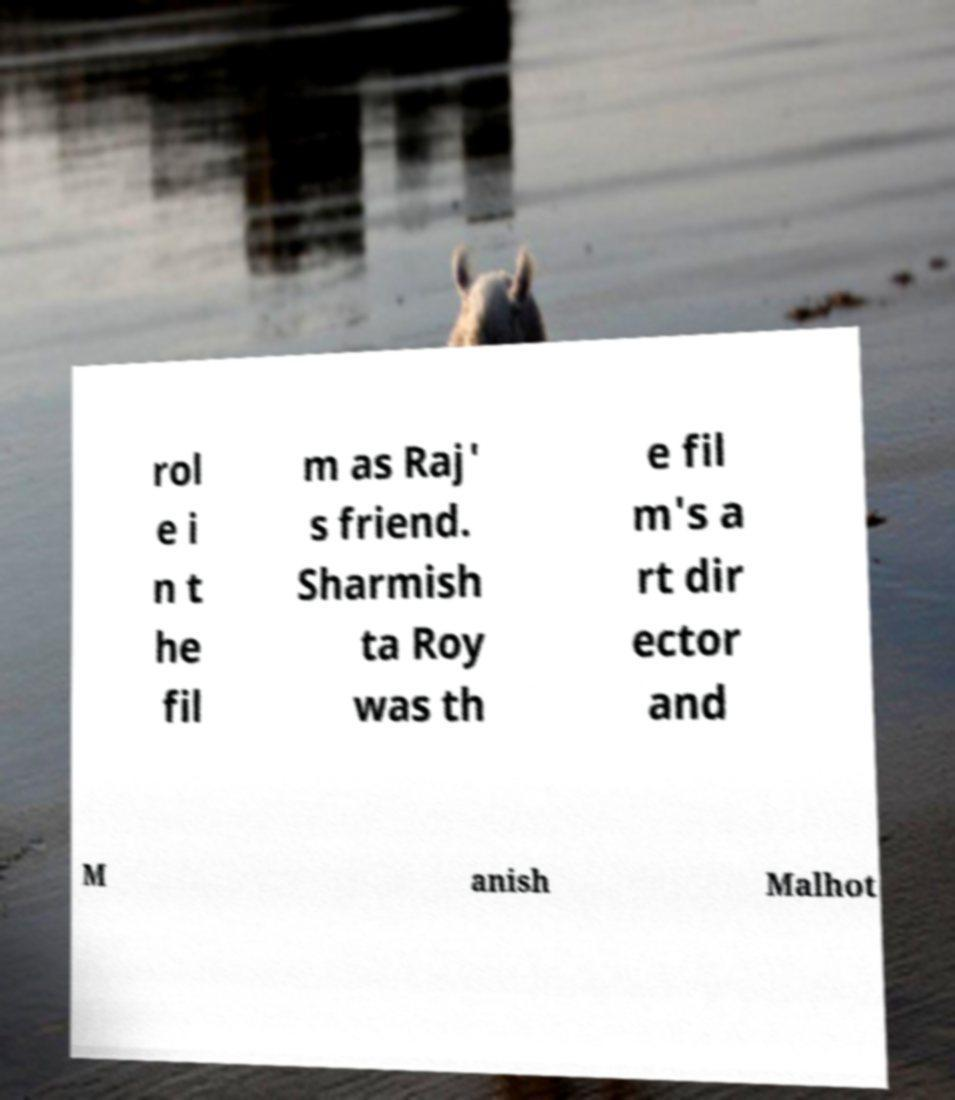For documentation purposes, I need the text within this image transcribed. Could you provide that? rol e i n t he fil m as Raj' s friend. Sharmish ta Roy was th e fil m's a rt dir ector and M anish Malhot 